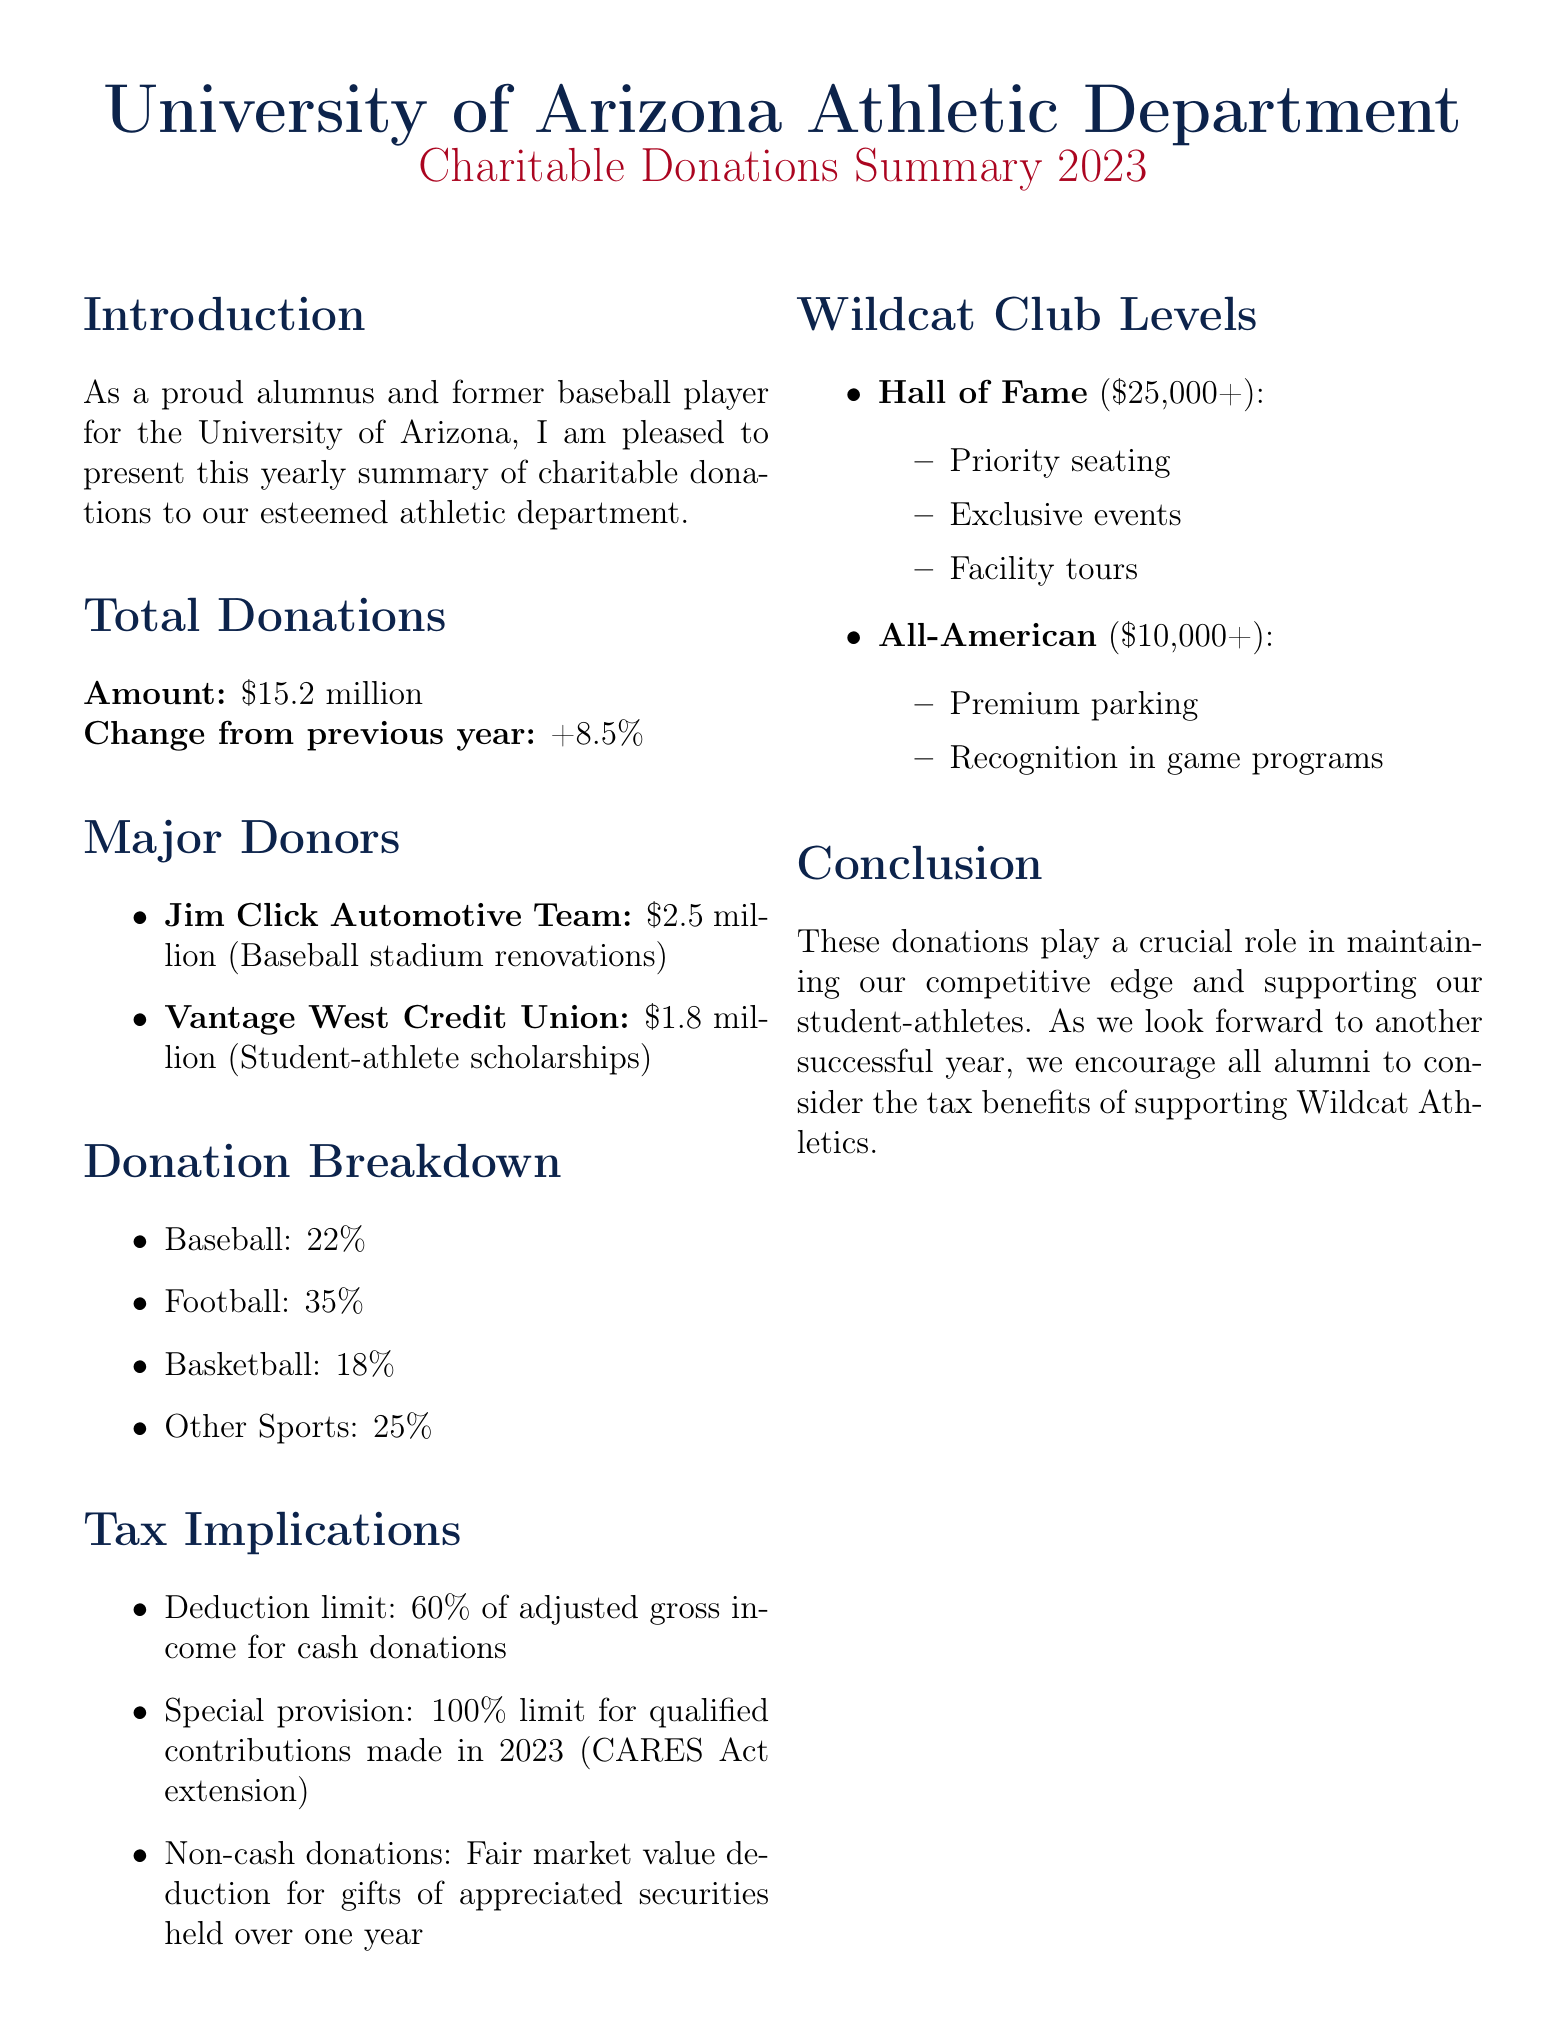What is the total amount of donations in 2023? The document states the total donations amount, which is detailed in the total donations section.
Answer: $15.2 million Who donated $2.5 million? The document lists major donors along with their donation amounts and purposes.
Answer: Jim Click Automotive Team What percentage of donations went to football? The donation breakdown provides specific percentage allocations for each sport.
Answer: 35% What is the special provision for tax deductions in 2023? The tax implications section highlights a special provision for contributions made in 2023.
Answer: 100% limit for qualified contributions made in 2023 How much is the minimum donation to reach the Hall of Fame level? The document outlines the different Wildcat Club levels along with their minimum donation requirements.
Answer: $25,000 Which sport received the least percentage of donations? The donation breakdown provides percentage allocations, allowing comparison across sports.
Answer: Basketball What benefits do All-American members receive? The Wildcat Club levels section lists benefits associated with specific donation levels.
Answer: Premium parking, recognition in game programs What was the change in donations from the previous year? The total donations section mentions the change compared to the previous year.
Answer: +8.5% What percentage of donations was earmarked for other sports? The donation breakdown specifies the allocation for different sports.
Answer: 25% 